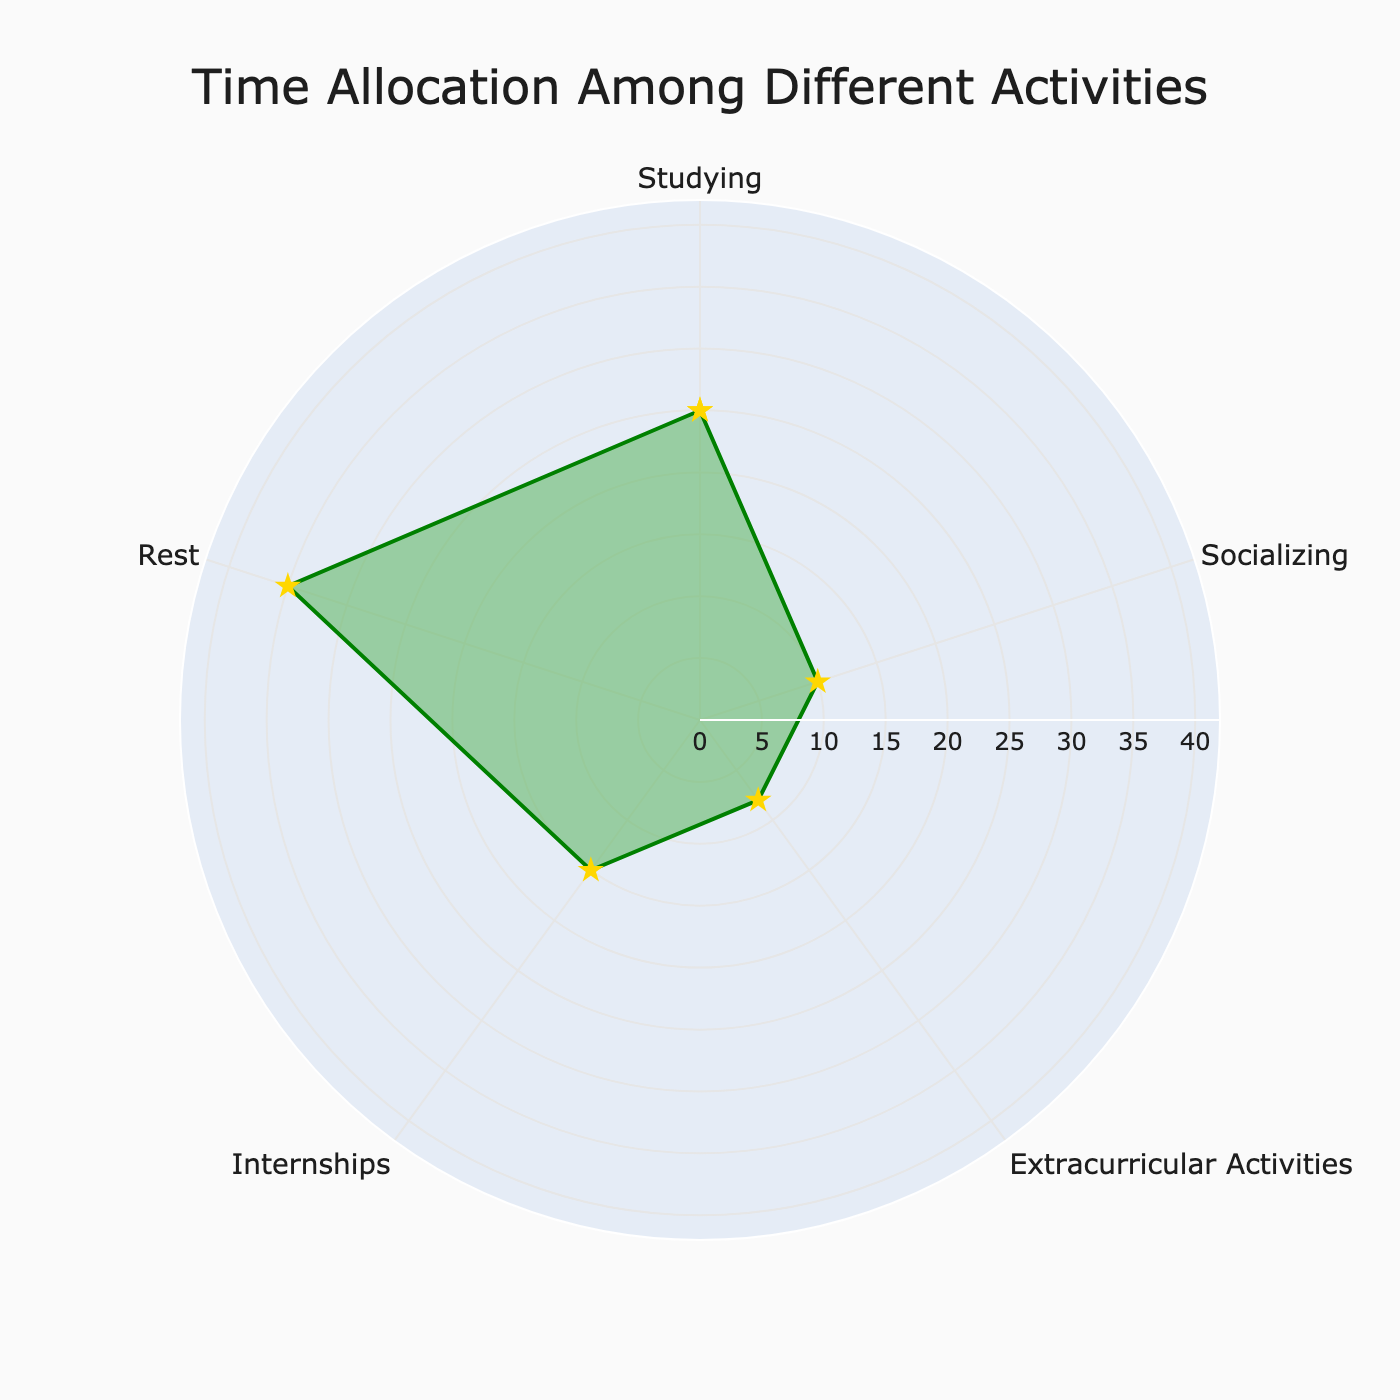What is the title of the radar chart? The title is prominently displayed at the top of the chart.
Answer: Time Allocation Among Different Activities How many activities are represented in the radar chart? Count the number of distinct categories (segments) in the radar chart, excluding the repeated starting point.
Answer: 5 What is the range of the radial axis in the chart? The radial axis range can be observed from the outermost circle, showing the maximum value multiplied by 1.2.
Answer: 0 to 42 Which activity has the highest time allocation? Identify the data point that reaches the furthest on the radial axis.
Answer: Rest What is the difference in time allocation between Studying and Socializing? Subtract the time allocation value of Socializing from that of Studying.
Answer: 15 hours Which two activities have the smallest difference in time allocation? Compare the values of all activities and find those with the closest values.
Answer: Extracurricular Activities and Socializing What is the average time allocation for all activities? Sum the time allocation values for all activities then divide by the number of activities (5).
Answer: 18.6 hours How much more time is allocated to Internships compared to Extracurricular Activities and Socializing combined? Add the time allocated to Extracurricular Activities and Socializing first, then subtract from the time allocated to Internships.
Answer: -3 hours Which activity has the lowest time allocation? The shortest value on the radial axis corresponds to the activity with the lowest time allocation.
Answer: Extracurricular Activities Is there any activity that has a time allocation more than twice that of Socializing? Compare each activity's time allocation to twice the value of Socializing.
Answer: Yes, Rest 